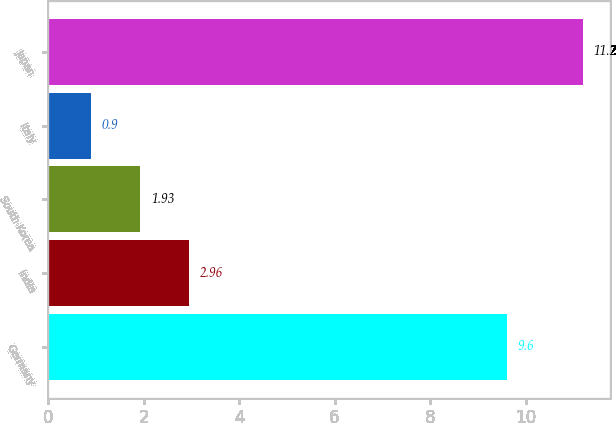<chart> <loc_0><loc_0><loc_500><loc_500><bar_chart><fcel>Germany<fcel>India<fcel>South Korea<fcel>Italy<fcel>Japan<nl><fcel>9.6<fcel>2.96<fcel>1.93<fcel>0.9<fcel>11.2<nl></chart> 